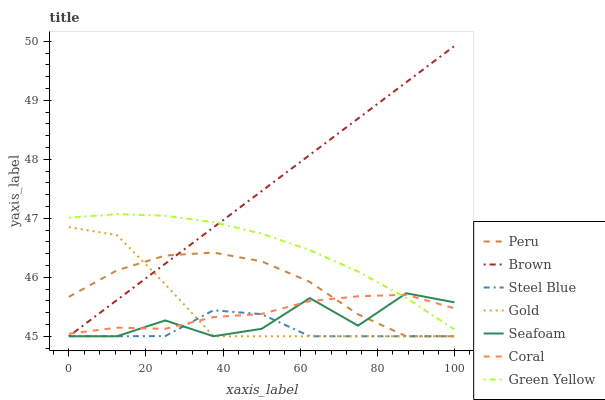Does Gold have the minimum area under the curve?
Answer yes or no. No. Does Gold have the maximum area under the curve?
Answer yes or no. No. Is Gold the smoothest?
Answer yes or no. No. Is Gold the roughest?
Answer yes or no. No. Does Coral have the lowest value?
Answer yes or no. No. Does Gold have the highest value?
Answer yes or no. No. Is Peru less than Green Yellow?
Answer yes or no. Yes. Is Green Yellow greater than Steel Blue?
Answer yes or no. Yes. Does Peru intersect Green Yellow?
Answer yes or no. No. 